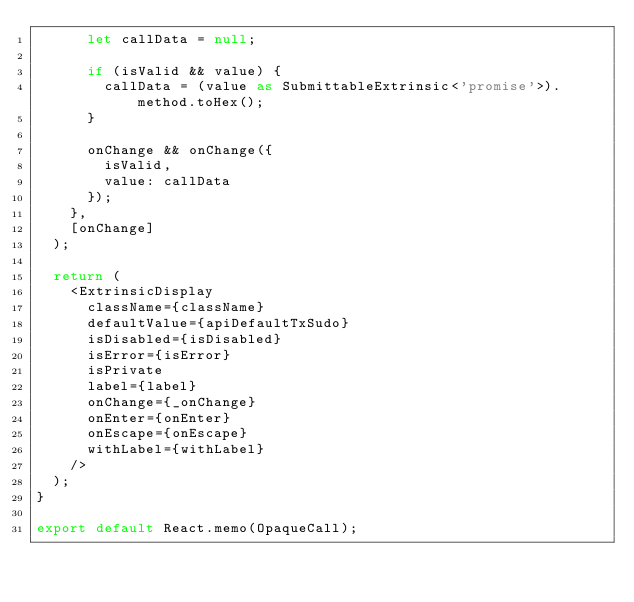<code> <loc_0><loc_0><loc_500><loc_500><_TypeScript_>      let callData = null;

      if (isValid && value) {
        callData = (value as SubmittableExtrinsic<'promise'>).method.toHex();
      }

      onChange && onChange({
        isValid,
        value: callData
      });
    },
    [onChange]
  );

  return (
    <ExtrinsicDisplay
      className={className}
      defaultValue={apiDefaultTxSudo}
      isDisabled={isDisabled}
      isError={isError}
      isPrivate
      label={label}
      onChange={_onChange}
      onEnter={onEnter}
      onEscape={onEscape}
      withLabel={withLabel}
    />
  );
}

export default React.memo(OpaqueCall);
</code> 